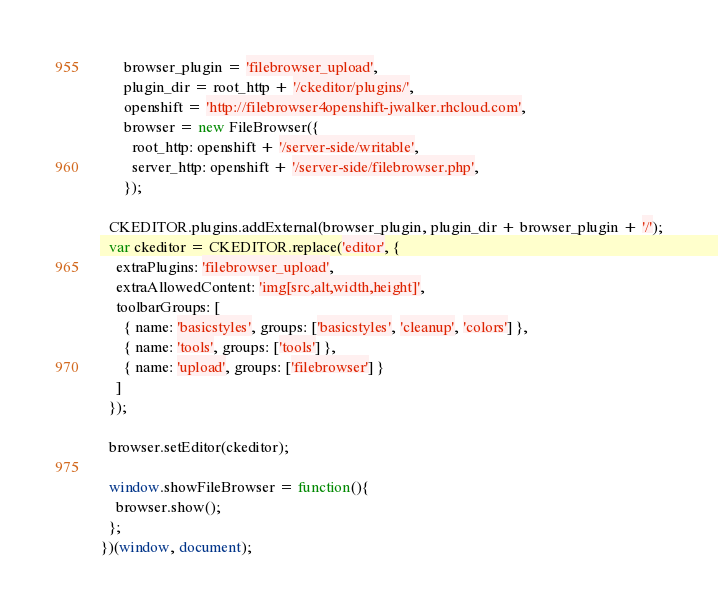<code> <loc_0><loc_0><loc_500><loc_500><_JavaScript_>      browser_plugin = 'filebrowser_upload',
      plugin_dir = root_http + '/ckeditor/plugins/',
      openshift = 'http://filebrowser4openshift-jwalker.rhcloud.com',
      browser = new FileBrowser({
        root_http: openshift + '/server-side/writable',
        server_http: openshift + '/server-side/filebrowser.php',
      });

  CKEDITOR.plugins.addExternal(browser_plugin, plugin_dir + browser_plugin + '/');
  var ckeditor = CKEDITOR.replace('editor', {
    extraPlugins: 'filebrowser_upload',
    extraAllowedContent: 'img[src,alt,width,height]',
    toolbarGroups: [
      { name: 'basicstyles', groups: ['basicstyles', 'cleanup', 'colors'] },
      { name: 'tools', groups: ['tools'] },
      { name: 'upload', groups: ['filebrowser'] }
    ]
  });
  
  browser.setEditor(ckeditor);

  window.showFileBrowser = function(){
    browser.show();
  };
})(window, document);

</code> 